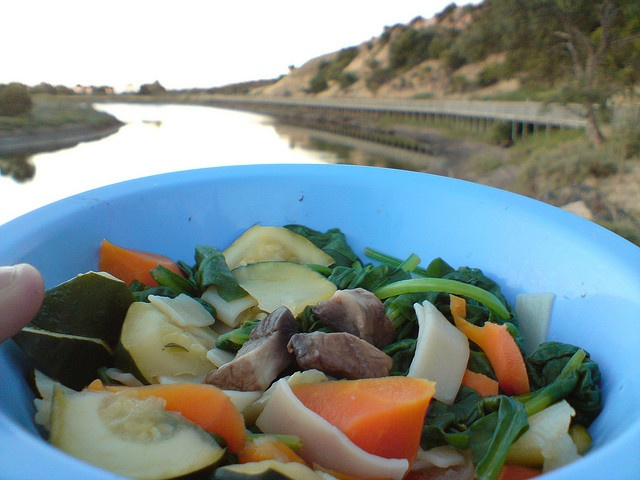Describe the objects in this image and their specific colors. I can see bowl in white, lightblue, black, darkgray, and gray tones, carrot in white, brown, tan, and red tones, broccoli in white, black, teal, and darkgreen tones, carrot in white, red, tan, maroon, and olive tones, and carrot in white, brown, maroon, and salmon tones in this image. 